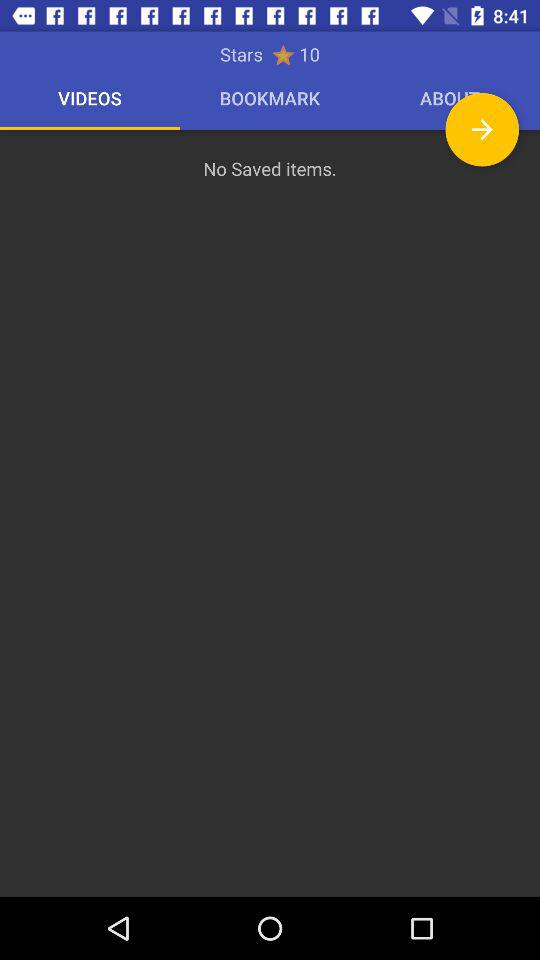Which tab is selected? The selected tab is "VIDEOS". 